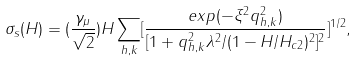Convert formula to latex. <formula><loc_0><loc_0><loc_500><loc_500>\sigma _ { s } ( H ) = ( \frac { \gamma _ { \mu } } { \sqrt { 2 } } ) H \sum _ { h , k } [ \frac { e x p ( - \xi ^ { 2 } q _ { h , k } ^ { 2 } ) } { [ 1 + q _ { h , k } ^ { 2 } \lambda ^ { 2 } / ( 1 - H / H _ { c 2 } ) ^ { 2 } ] ^ { 2 } } ] ^ { 1 / 2 } ,</formula> 